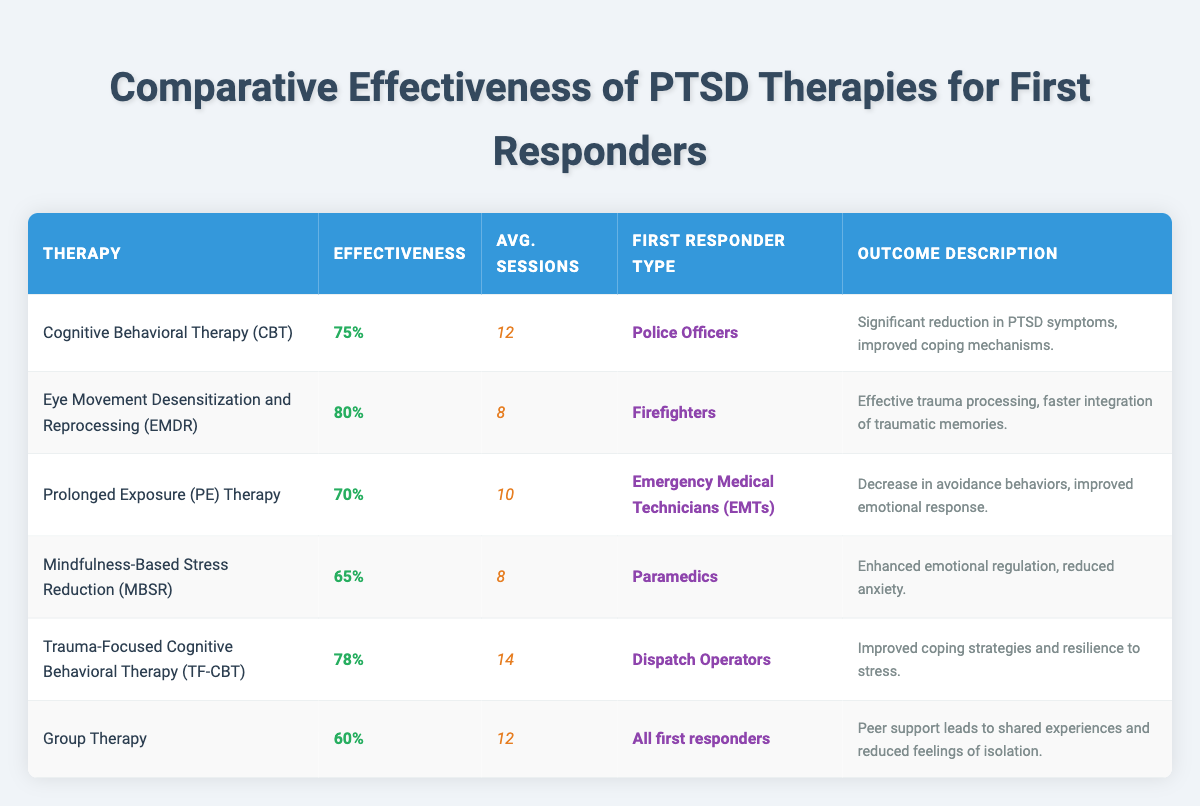What is the effectiveness percentage of Eye Movement Desensitization and Reprocessing therapy? The table lists the effectiveness percentage of Eye Movement Desensitization and Reprocessing therapy, which is specifically mentioned in the corresponding row. It shows an effectiveness percentage of 80%.
Answer: 80% Which therapy has the lowest effectiveness percentage? The table shows the effectiveness percentages for each therapy. By comparing them, we find that Group Therapy has the lowest value at 60%.
Answer: Group Therapy How many average sessions are required for Trauma-Focused Cognitive Behavioral Therapy? The table includes a column for the average sessions for each therapy, and for Trauma-Focused Cognitive Behavioral Therapy, it is stated that 14 sessions are required.
Answer: 14 Is there any therapy with an effectiveness percentage of over 75% that requires less than 10 average sessions? By examining both columns for effectiveness percentage and average sessions, it is clear that Eye Movement Desensitization and Reprocessing therapy (80%, 8 sessions) meets these criteria.
Answer: Yes What is the average effectiveness percentage of all therapies listed? First, we sum the effectiveness percentages: 75 + 80 + 70 + 65 + 78 + 60 = 428. Then, we divide this sum by the number of therapies (6): 428 / 6 = 71.33. The average effectiveness percentage is approximately 71.33%.
Answer: 71.33% Among the therapies, which one provides significant reduction in PTSD symptoms for Police Officers? The table lists Cognitive Behavioral Therapy as the therapy designated for Police Officers, with an outcome describing significant reduction in PTSD symptoms and improved coping mechanisms.
Answer: Cognitive Behavioral Therapy What is the range of average sessions required among all the therapies? The average sessions range can be determined by finding the maximum and minimum values from the average sessions column. The maximum is 14 sessions (TF-CBT) and the minimum is 8 sessions (EMDR and MBSR), so the range is 14 - 8 = 6 sessions.
Answer: 6 sessions Do all therapies have a different first responder type? Looking at the first responder type column, we can see that each therapy is associated with either a specific type of first responder or a broader category. For instance, Group Therapy is listed under "All first responders," indicating it is not unique to a single type. Hence, not all therapies have a wholly different first responder type.
Answer: No 